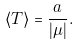Convert formula to latex. <formula><loc_0><loc_0><loc_500><loc_500>\langle T \rangle = \frac { a } { | \mu | } .</formula> 